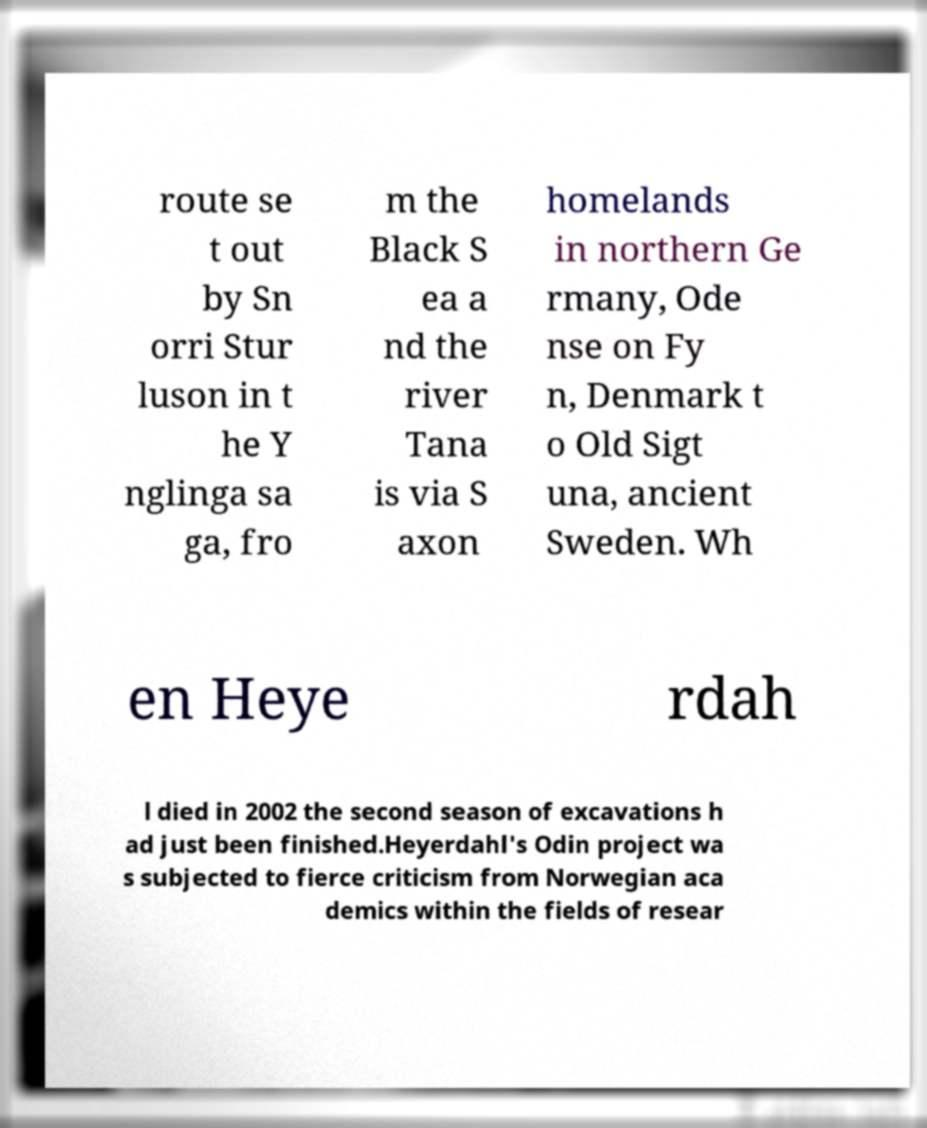What messages or text are displayed in this image? I need them in a readable, typed format. route se t out by Sn orri Stur luson in t he Y nglinga sa ga, fro m the Black S ea a nd the river Tana is via S axon homelands in northern Ge rmany, Ode nse on Fy n, Denmark t o Old Sigt una, ancient Sweden. Wh en Heye rdah l died in 2002 the second season of excavations h ad just been finished.Heyerdahl's Odin project wa s subjected to fierce criticism from Norwegian aca demics within the fields of resear 